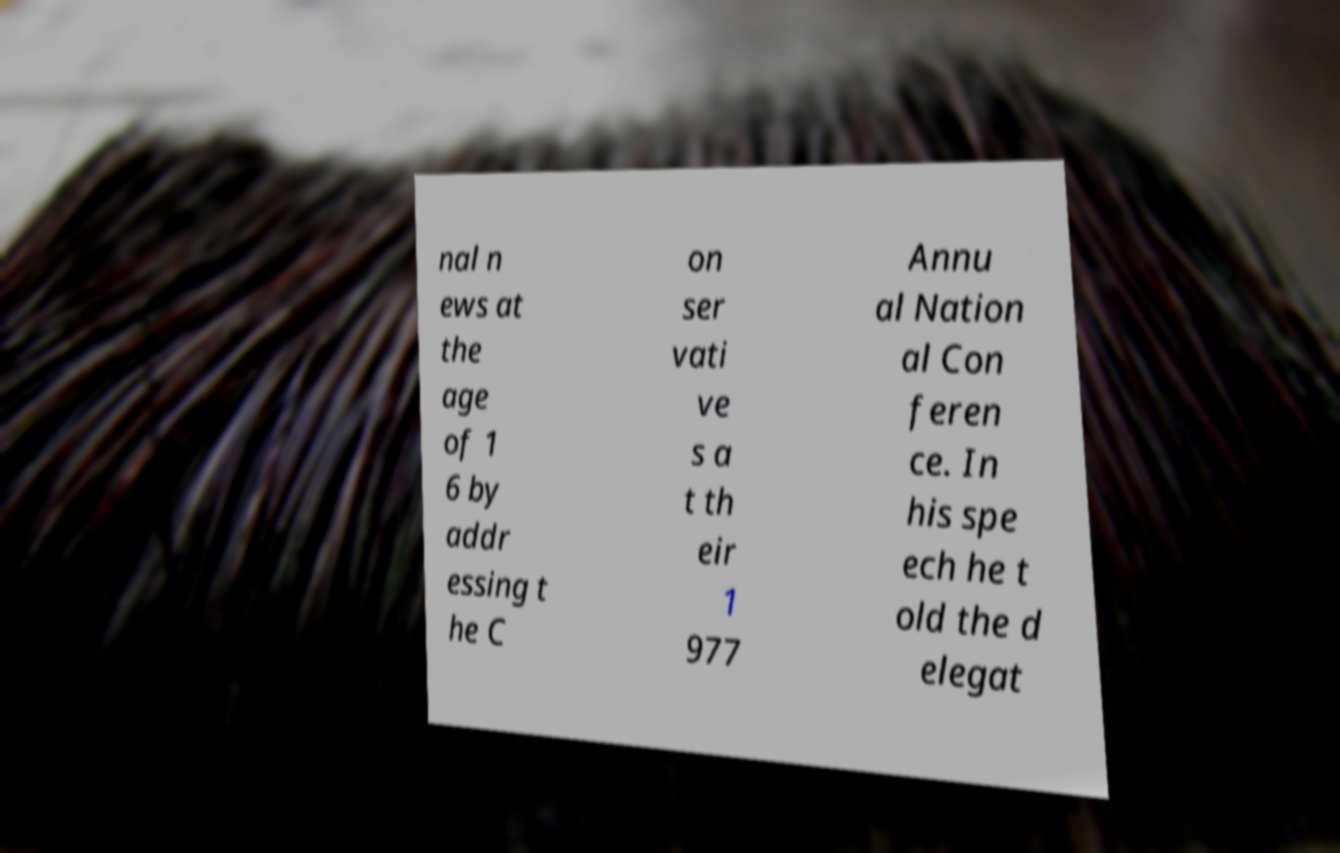Could you extract and type out the text from this image? nal n ews at the age of 1 6 by addr essing t he C on ser vati ve s a t th eir 1 977 Annu al Nation al Con feren ce. In his spe ech he t old the d elegat 